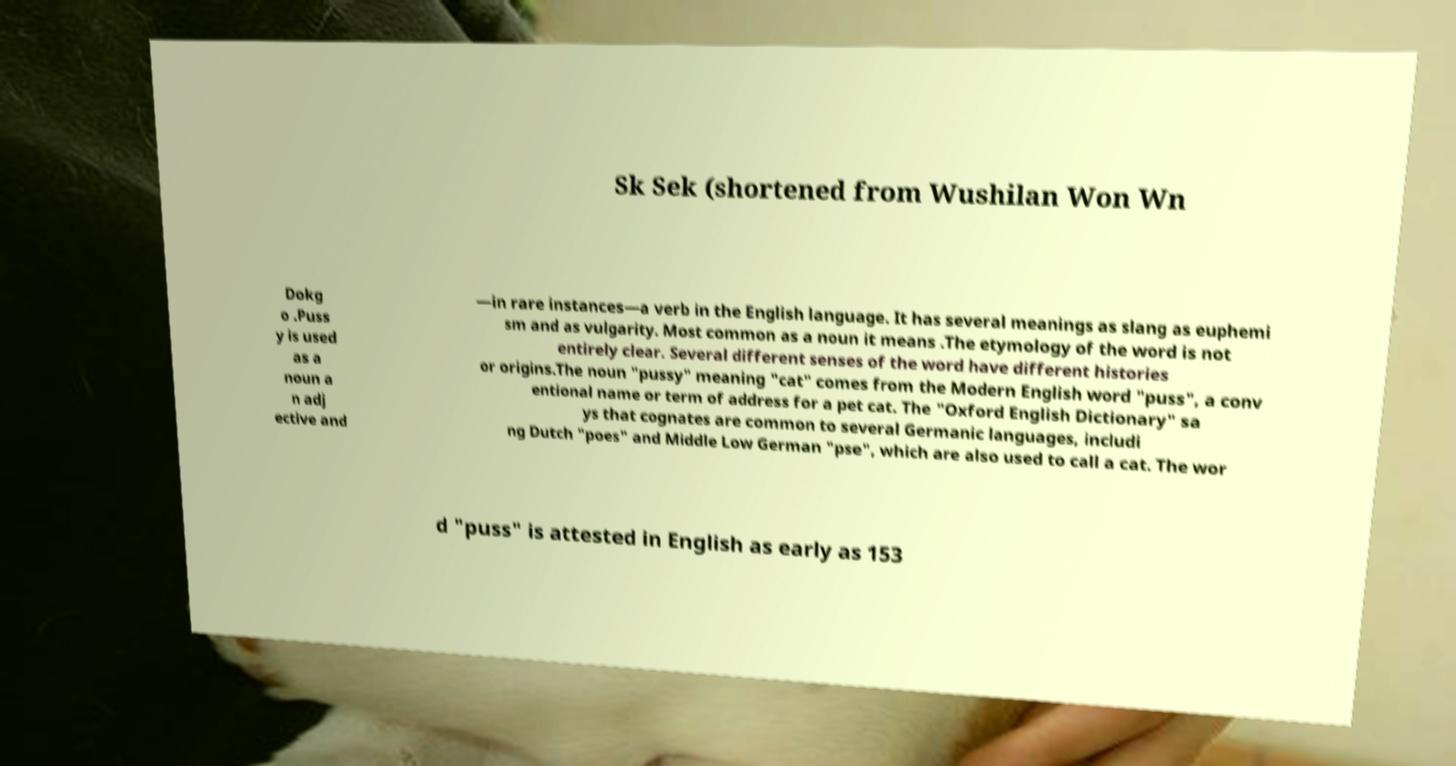Please read and relay the text visible in this image. What does it say? Sk Sek (shortened from Wushilan Won Wn Dokg o .Puss y is used as a noun a n adj ective and —in rare instances—a verb in the English language. It has several meanings as slang as euphemi sm and as vulgarity. Most common as a noun it means .The etymology of the word is not entirely clear. Several different senses of the word have different histories or origins.The noun "pussy" meaning "cat" comes from the Modern English word "puss", a conv entional name or term of address for a pet cat. The "Oxford English Dictionary" sa ys that cognates are common to several Germanic languages, includi ng Dutch "poes" and Middle Low German "pse", which are also used to call a cat. The wor d "puss" is attested in English as early as 153 